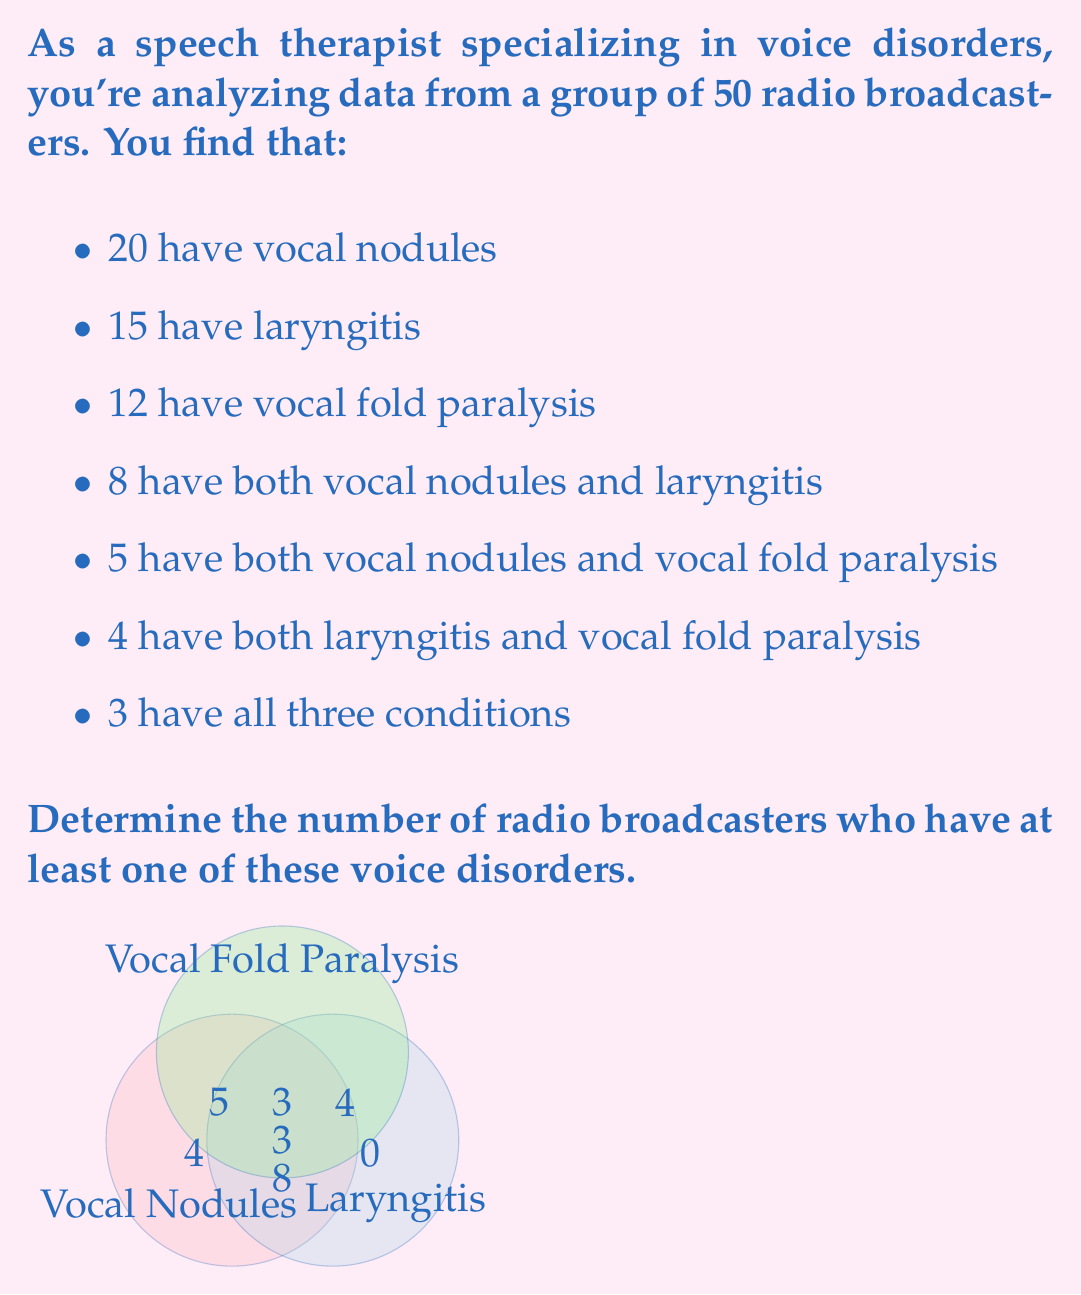Solve this math problem. To solve this problem, we'll use the principle of inclusion-exclusion for three sets. Let's define our sets:

$A$: Broadcasters with vocal nodules
$B$: Broadcasters with laryngitis
$C$: Broadcasters with vocal fold paralysis

We're given:
$|A| = 20$, $|B| = 15$, $|C| = 12$
$|A \cap B| = 8$, $|A \cap C| = 5$, $|B \cap C| = 4$
$|A \cap B \cap C| = 3$

The formula for the union of three sets is:

$$|A \cup B \cup C| = |A| + |B| + |C| - |A \cap B| - |A \cap C| - |B \cap C| + |A \cap B \cap C|$$

Substituting our values:

$$|A \cup B \cup C| = 20 + 15 + 12 - 8 - 5 - 4 + 3$$

Simplifying:
$$|A \cup B \cup C| = 47 - 17 + 3 = 33$$

Therefore, 33 radio broadcasters have at least one of these voice disorders.
Answer: 33 